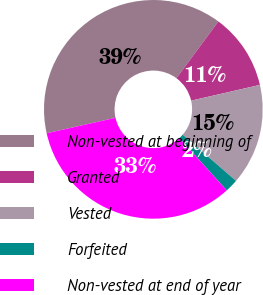Convert chart. <chart><loc_0><loc_0><loc_500><loc_500><pie_chart><fcel>Non-vested at beginning of<fcel>Granted<fcel>Vested<fcel>Forfeited<fcel>Non-vested at end of year<nl><fcel>38.66%<fcel>11.27%<fcel>14.94%<fcel>1.94%<fcel>33.2%<nl></chart> 